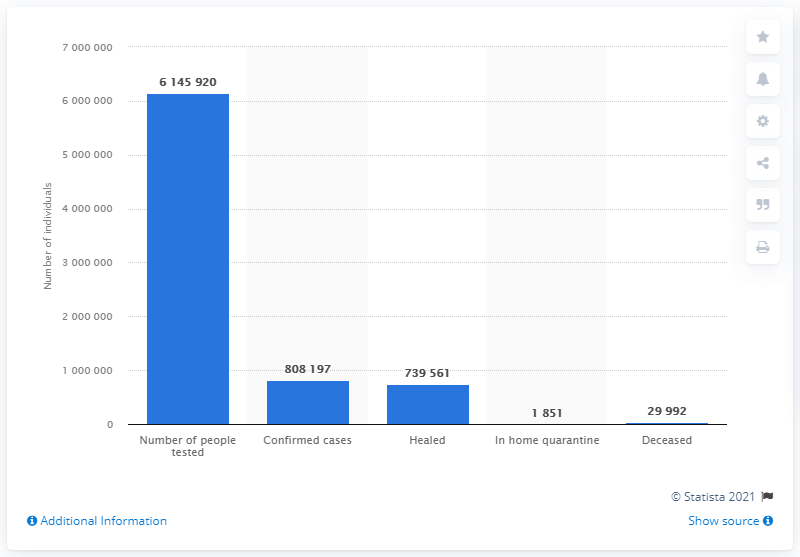Mention a couple of crucial points in this snapshot. As of January 26, 2023, there have been 1851 individuals placed in home quarantine as a result of their recent travel history to areas affected by the COVID-19 pandemic. There are 68,636 confirmed cases and healed people. 